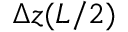<formula> <loc_0><loc_0><loc_500><loc_500>\Delta z ( L / 2 )</formula> 